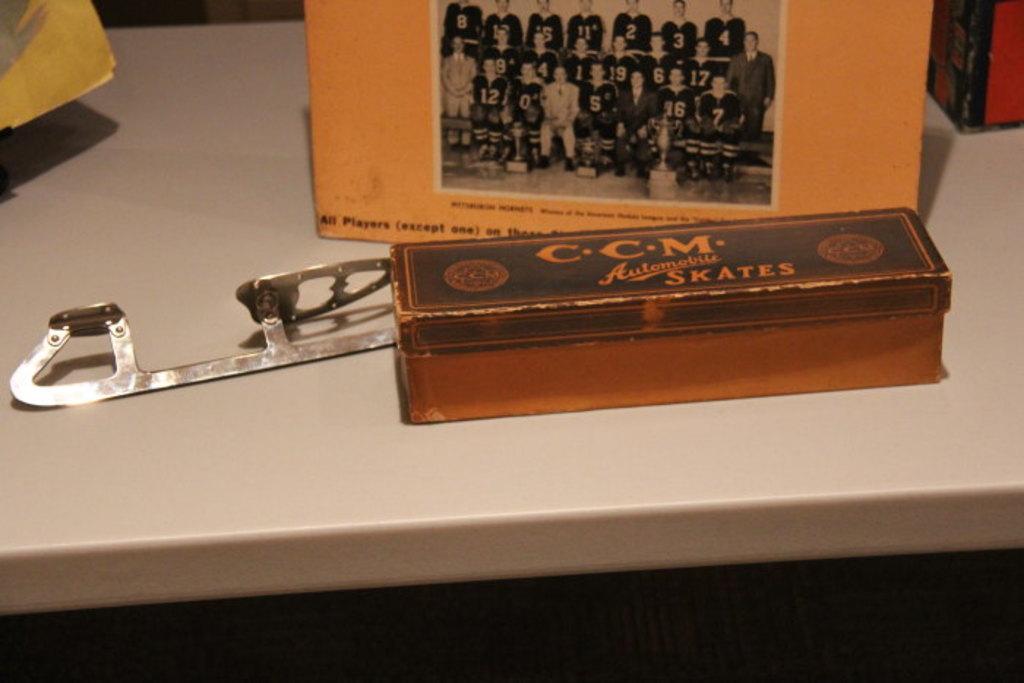What does the box hold?
Keep it short and to the point. Skates. 